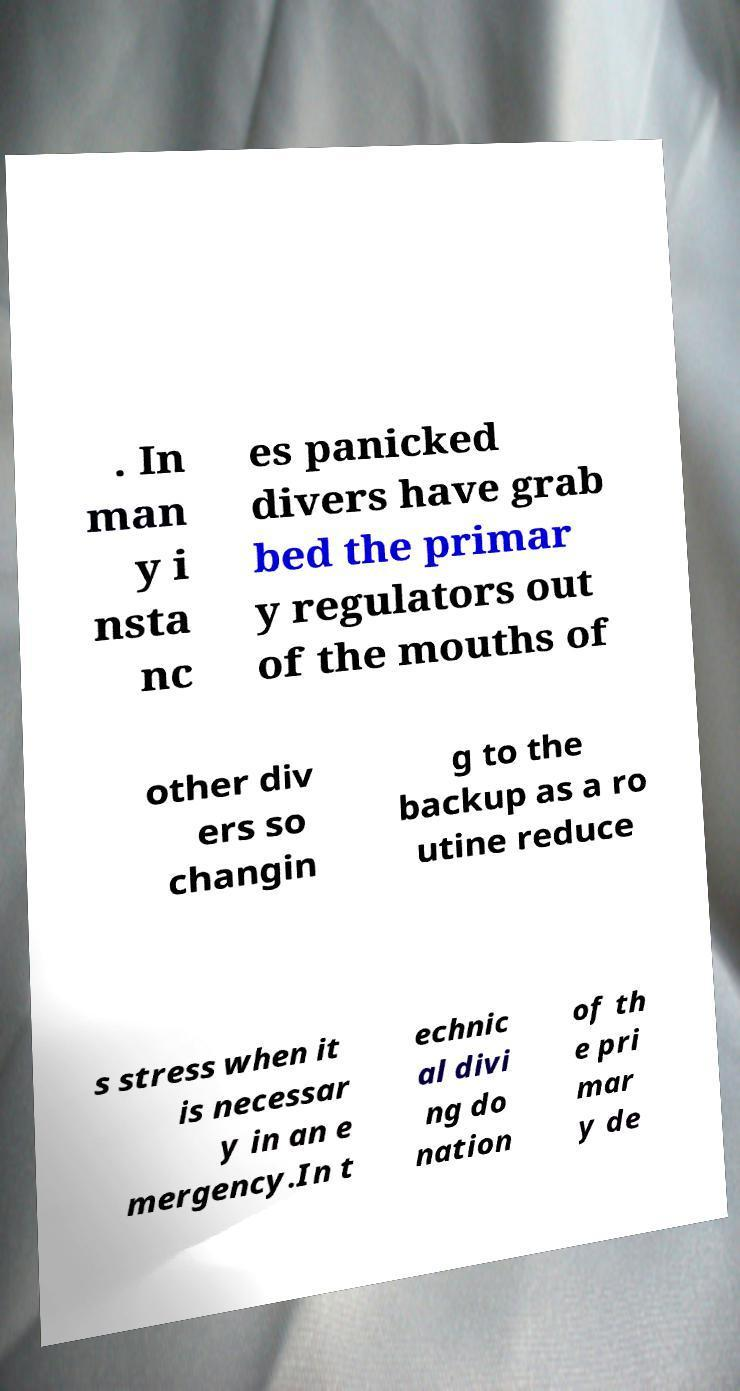Could you assist in decoding the text presented in this image and type it out clearly? . In man y i nsta nc es panicked divers have grab bed the primar y regulators out of the mouths of other div ers so changin g to the backup as a ro utine reduce s stress when it is necessar y in an e mergency.In t echnic al divi ng do nation of th e pri mar y de 